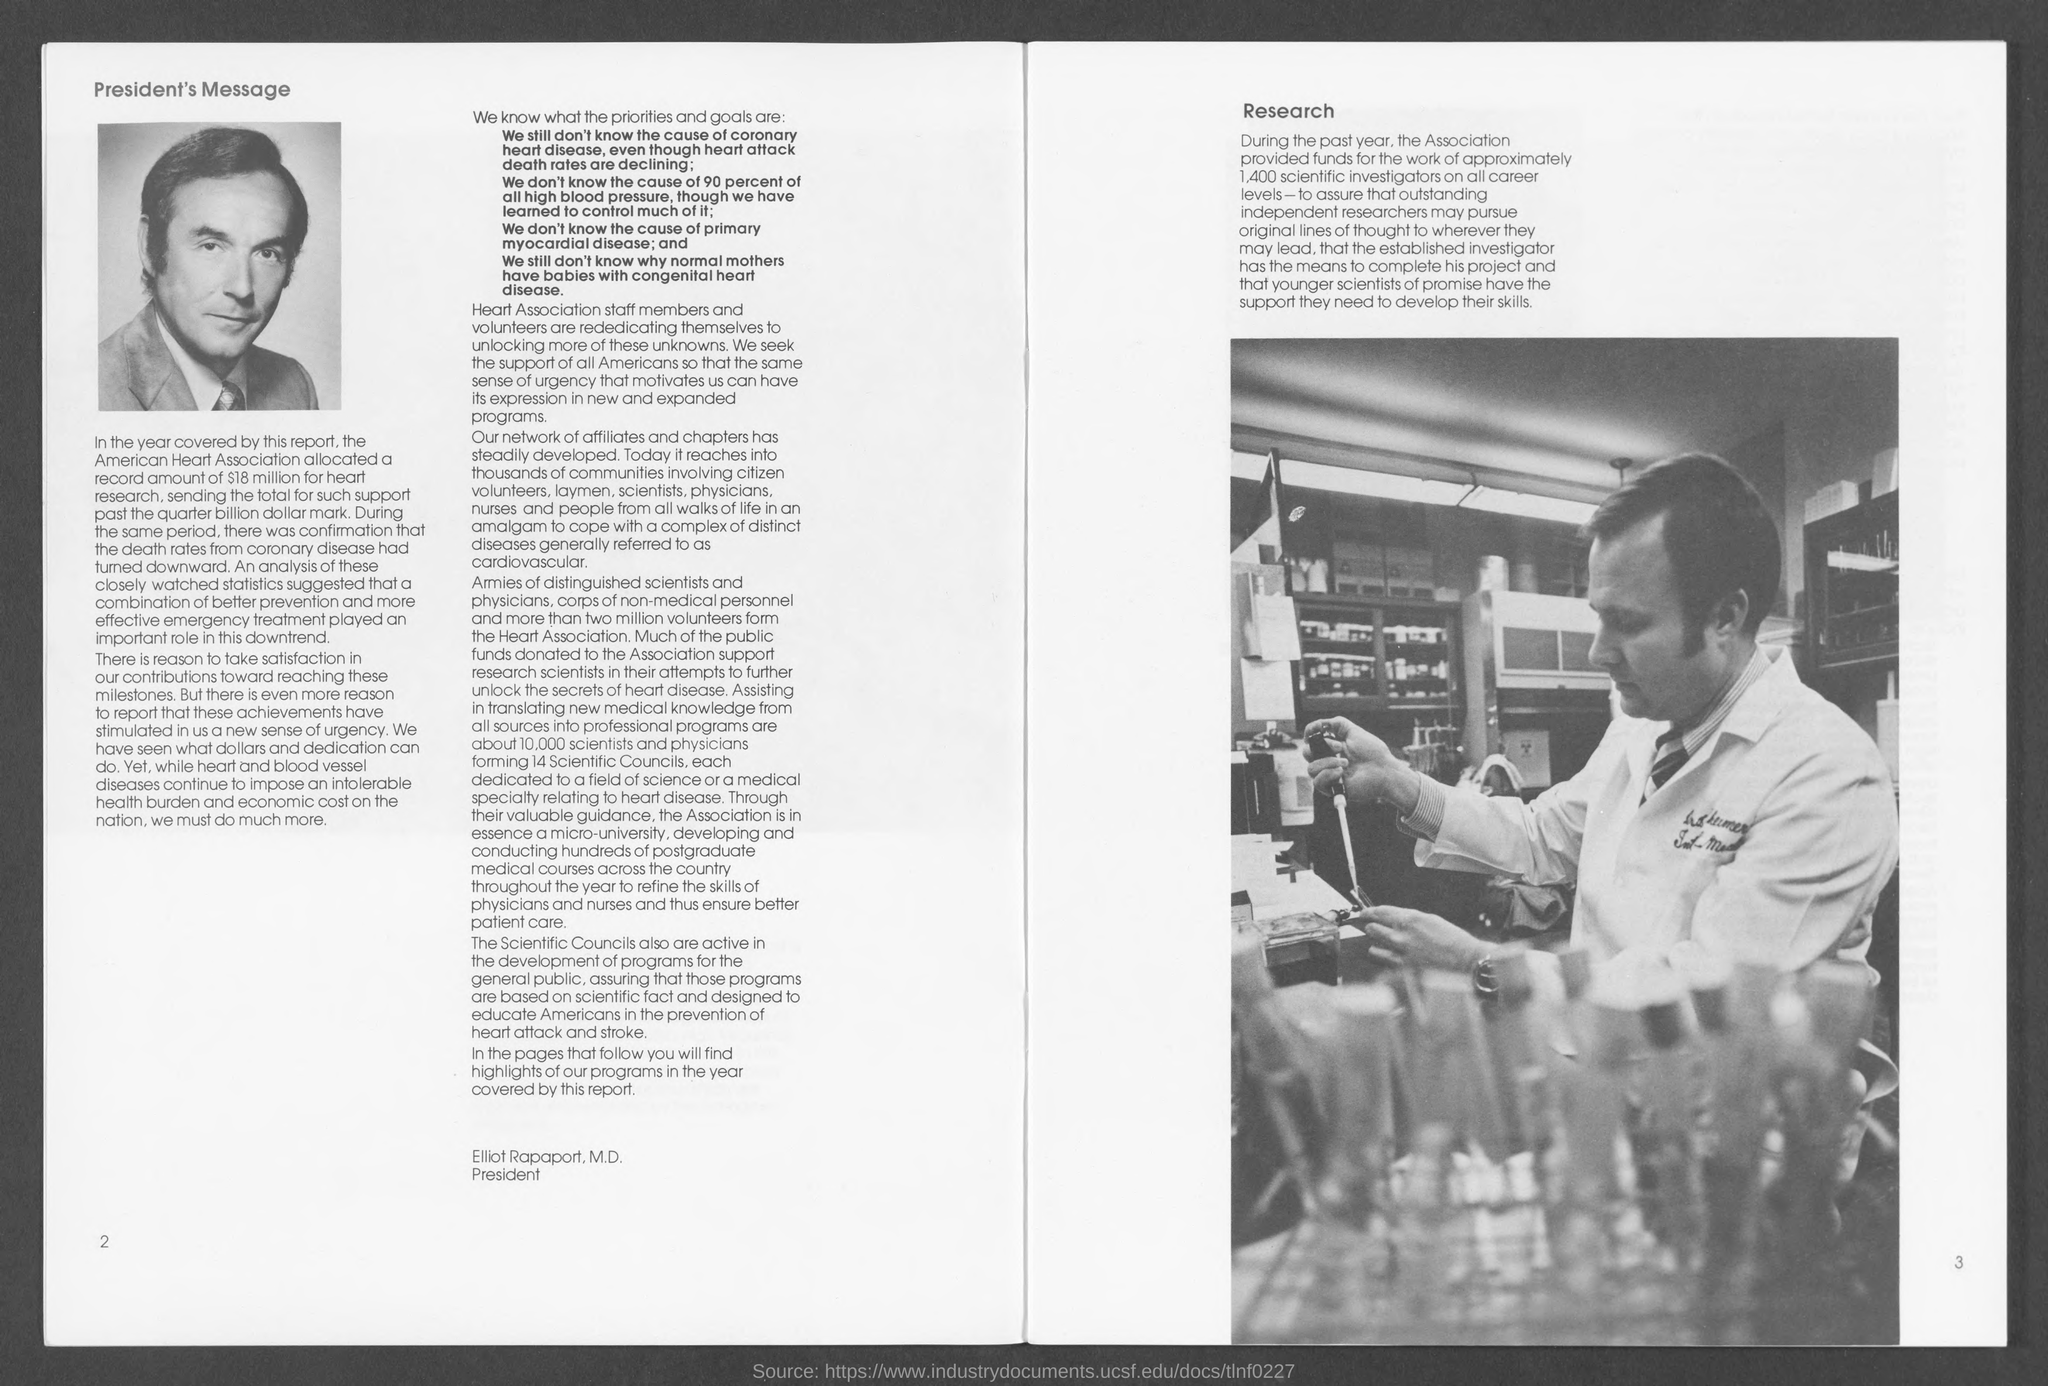What is the position of elliot rapaport, m.d.?
Ensure brevity in your answer.  President. What is the number at bottom left side ?
Keep it short and to the point. 2. What is the number at bottom right side ?
Offer a terse response. 3. 